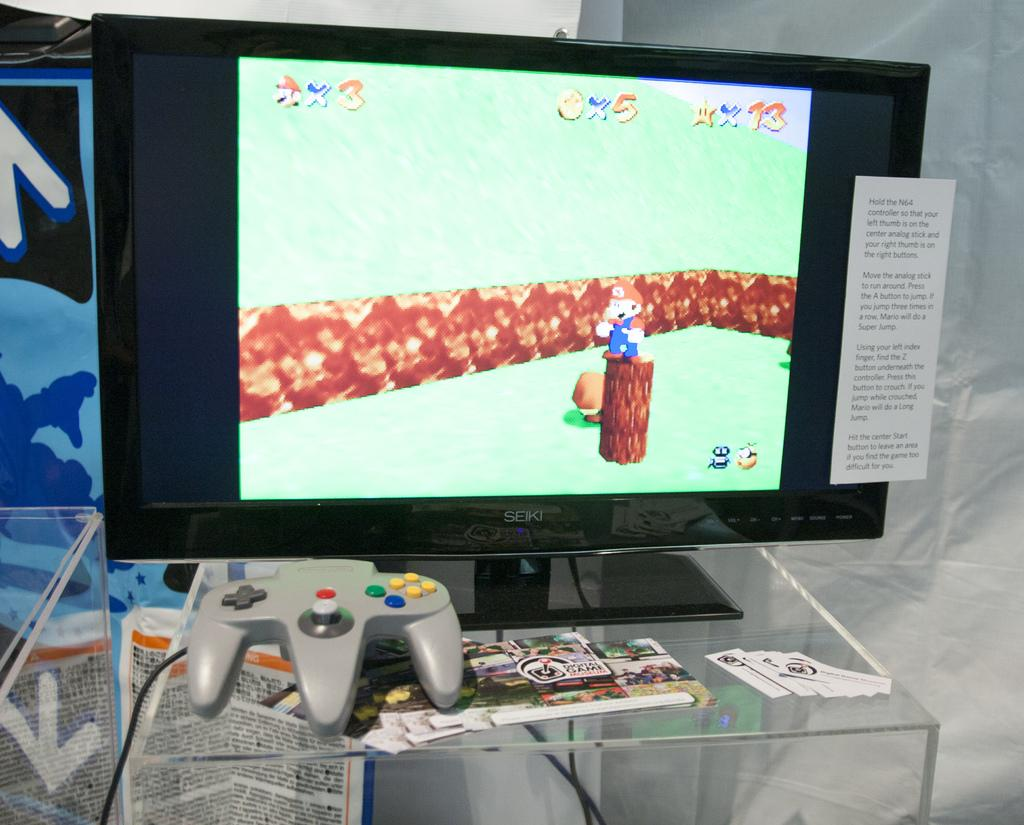Provide a one-sentence caption for the provided image. a computer monitor with a picture of a  face and x3 on the top left corner. 